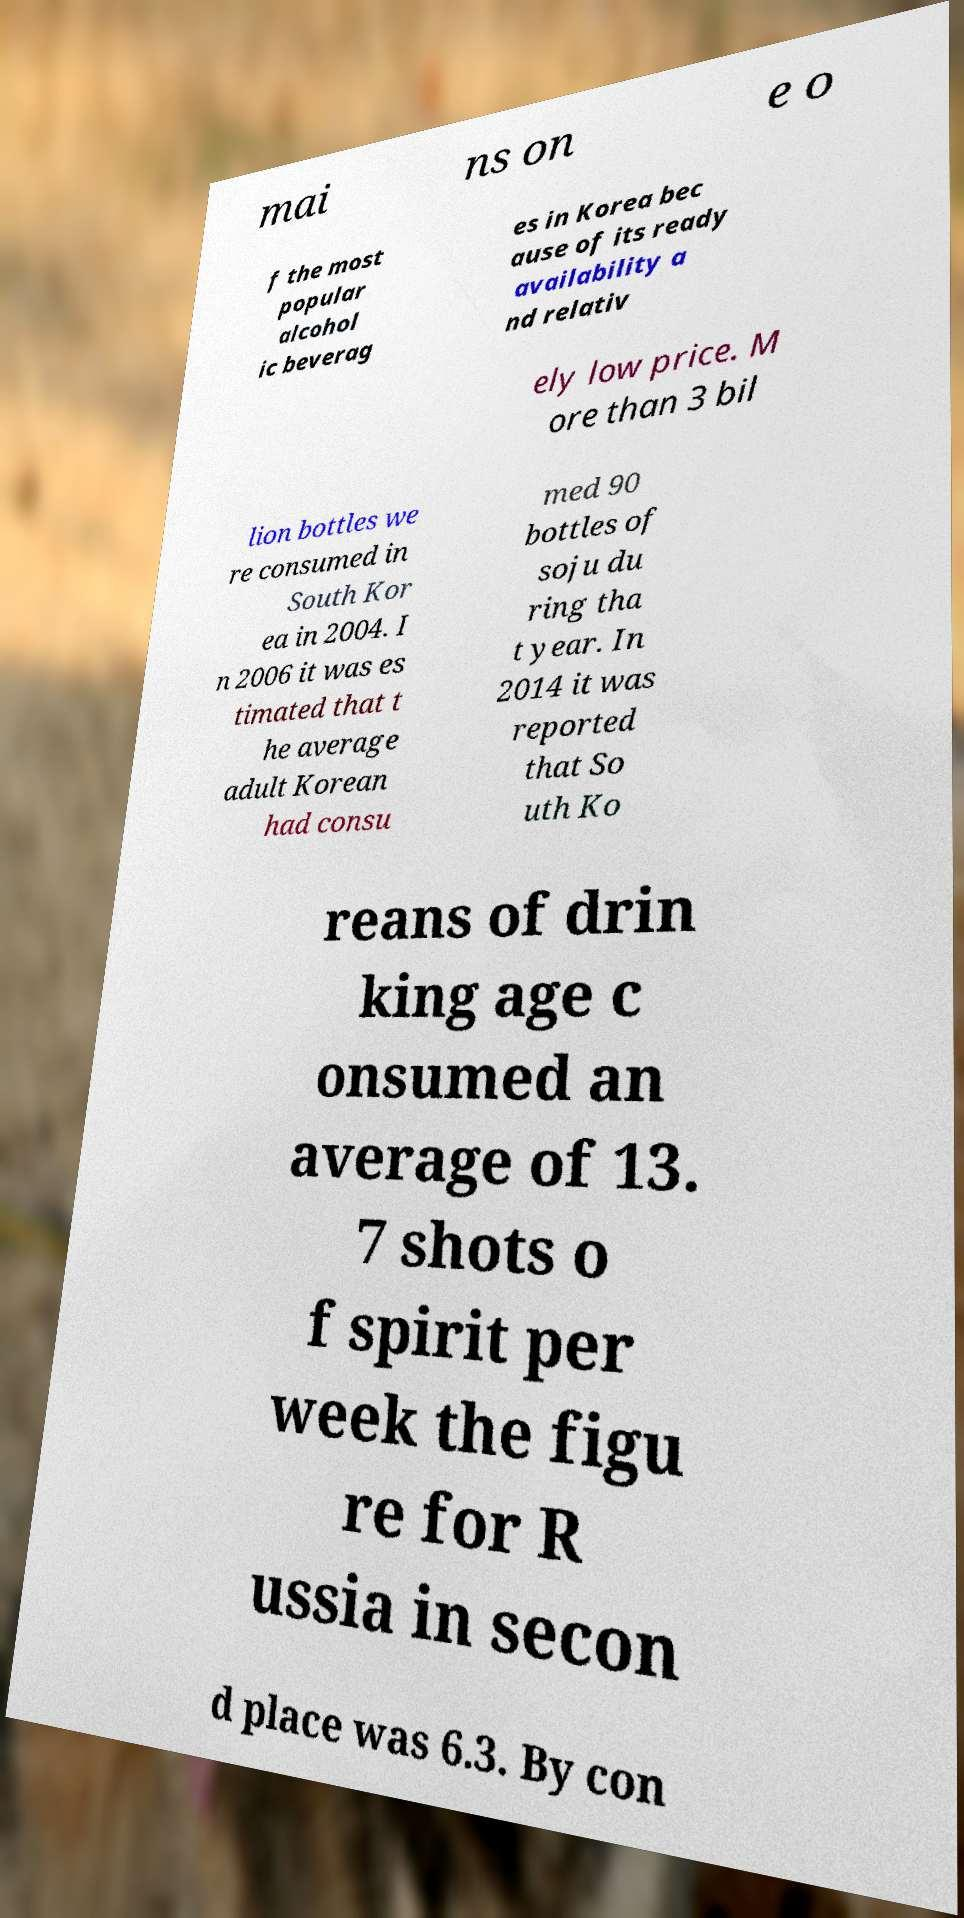Could you assist in decoding the text presented in this image and type it out clearly? mai ns on e o f the most popular alcohol ic beverag es in Korea bec ause of its ready availability a nd relativ ely low price. M ore than 3 bil lion bottles we re consumed in South Kor ea in 2004. I n 2006 it was es timated that t he average adult Korean had consu med 90 bottles of soju du ring tha t year. In 2014 it was reported that So uth Ko reans of drin king age c onsumed an average of 13. 7 shots o f spirit per week the figu re for R ussia in secon d place was 6.3. By con 